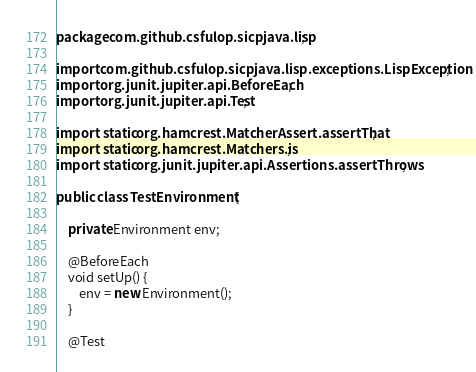<code> <loc_0><loc_0><loc_500><loc_500><_Java_>package com.github.csfulop.sicpjava.lisp;

import com.github.csfulop.sicpjava.lisp.exceptions.LispException;
import org.junit.jupiter.api.BeforeEach;
import org.junit.jupiter.api.Test;

import static org.hamcrest.MatcherAssert.assertThat;
import static org.hamcrest.Matchers.is;
import static org.junit.jupiter.api.Assertions.assertThrows;

public class TestEnvironment {

    private Environment env;

    @BeforeEach
    void setUp() {
        env = new Environment();
    }

    @Test</code> 